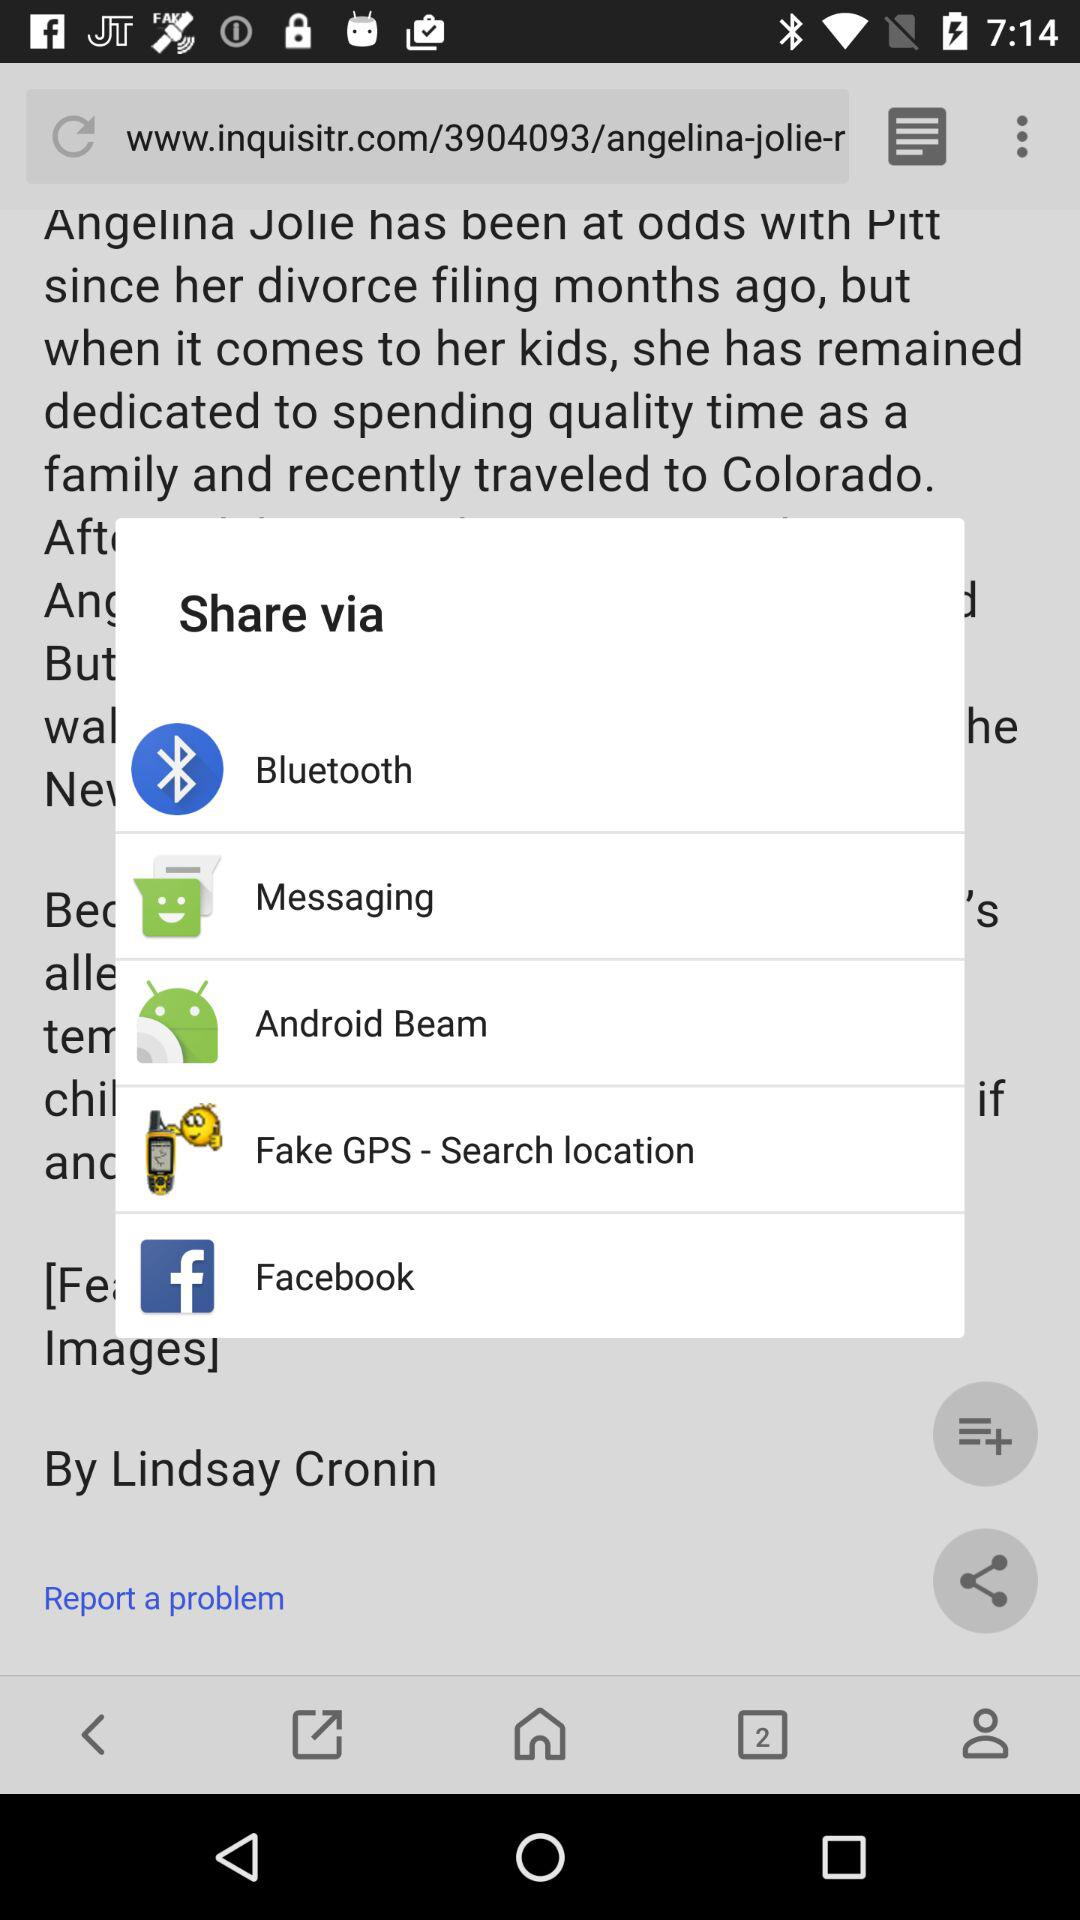Through which applications can we share? You can share through "Bluetooth", "Messaging", "Android Beam", "Fake GPS - Search location" and "Facebook". 